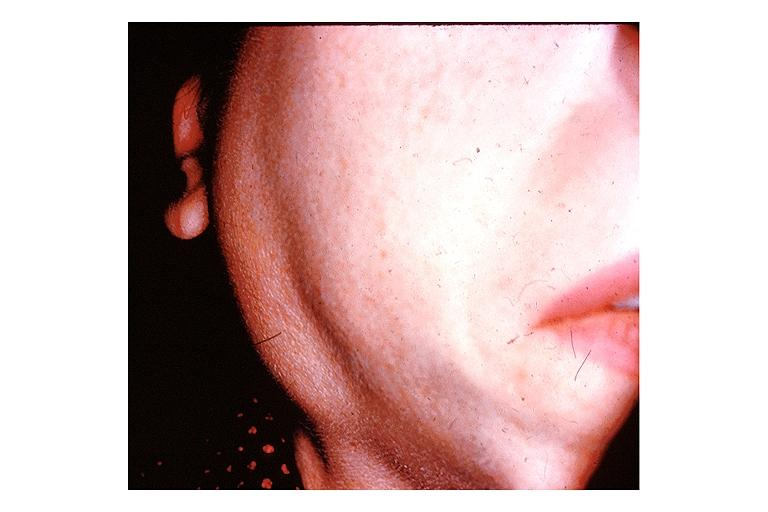what is present?
Answer the question using a single word or phrase. Oral 